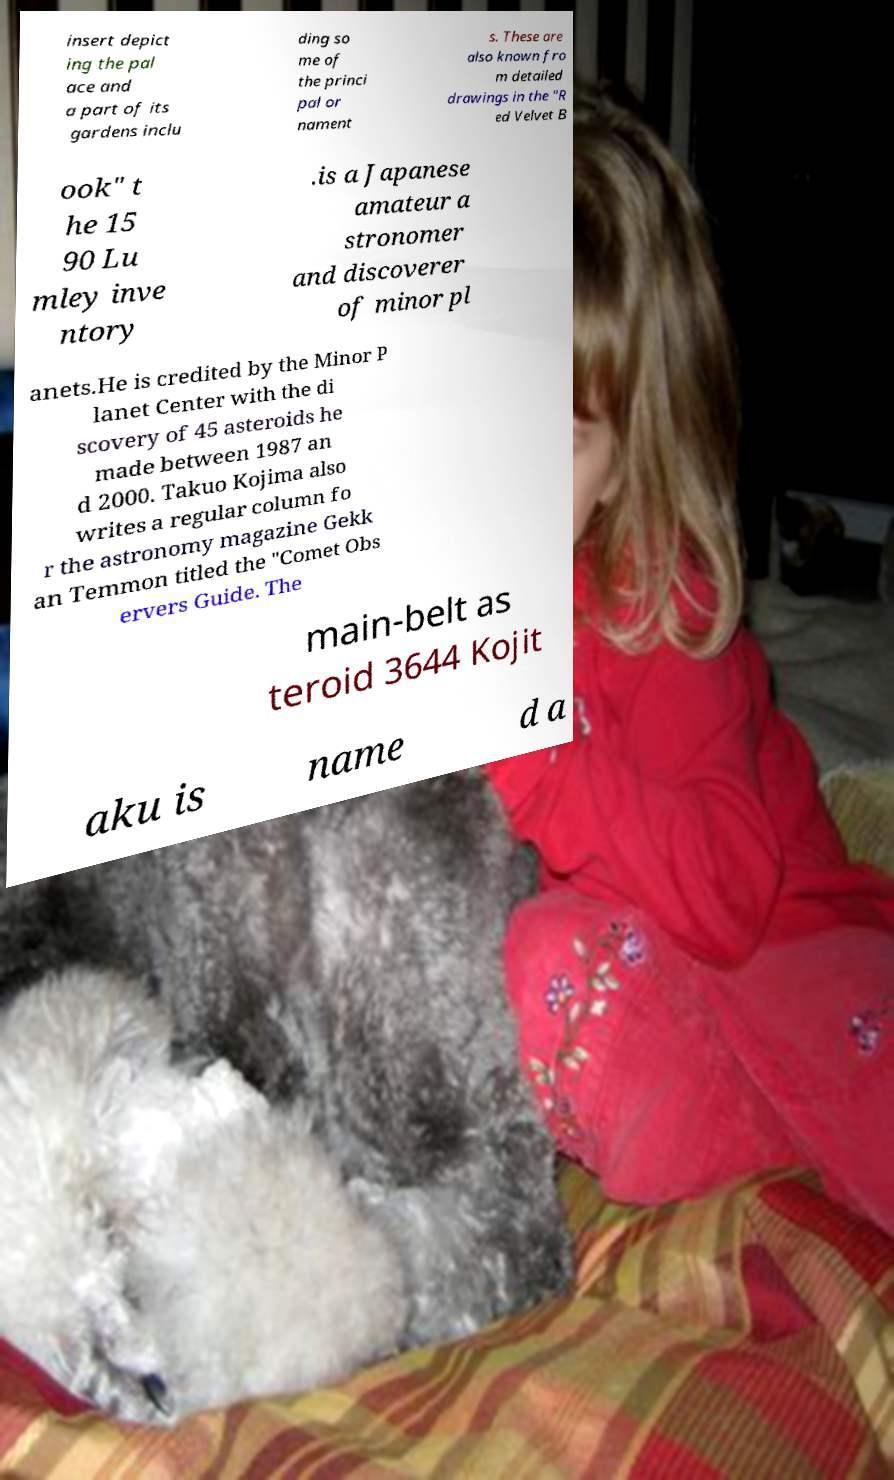There's text embedded in this image that I need extracted. Can you transcribe it verbatim? insert depict ing the pal ace and a part of its gardens inclu ding so me of the princi pal or nament s. These are also known fro m detailed drawings in the "R ed Velvet B ook" t he 15 90 Lu mley inve ntory .is a Japanese amateur a stronomer and discoverer of minor pl anets.He is credited by the Minor P lanet Center with the di scovery of 45 asteroids he made between 1987 an d 2000. Takuo Kojima also writes a regular column fo r the astronomy magazine Gekk an Temmon titled the "Comet Obs ervers Guide. The main-belt as teroid 3644 Kojit aku is name d a 